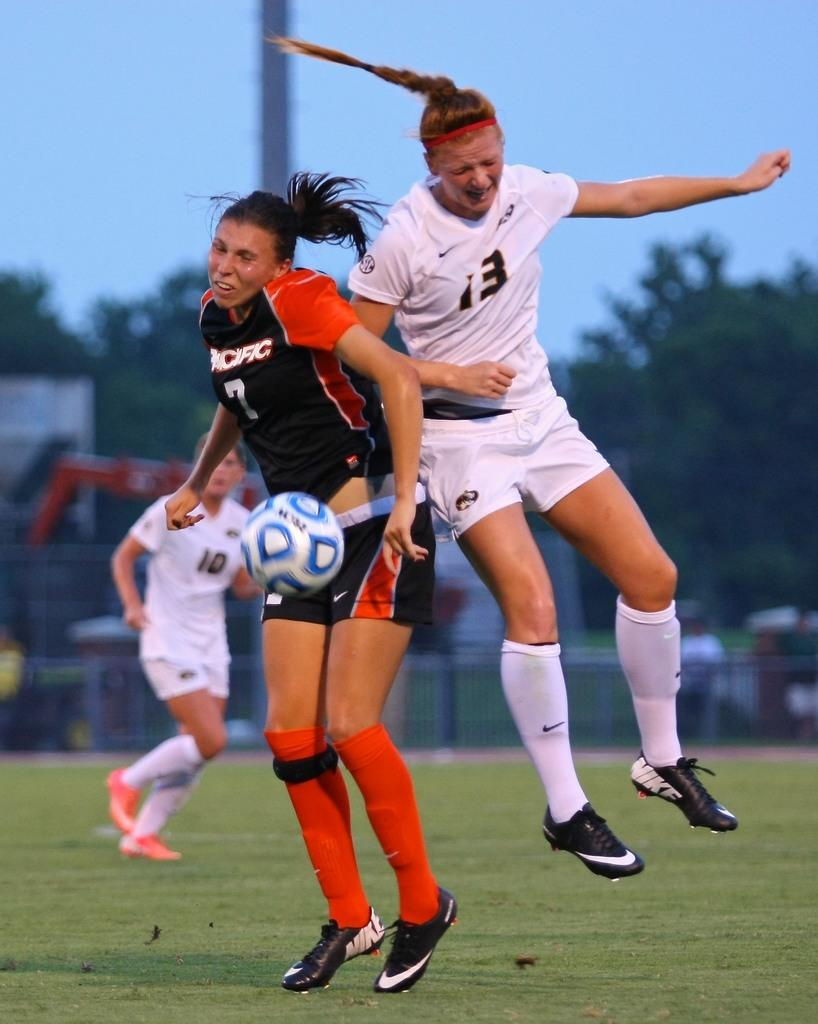Provide a one-sentence caption for the provided image. girls playing soccer and one is from the pacific. 